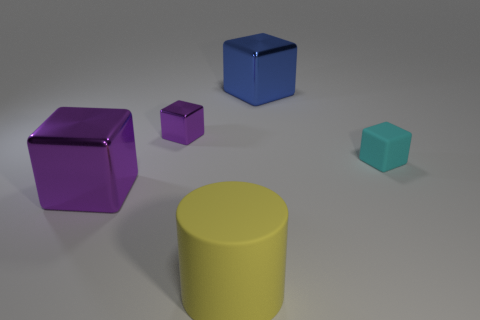There is a yellow matte cylinder; is its size the same as the object that is right of the blue metal object?
Your answer should be compact. No. The object that is both to the right of the yellow cylinder and on the left side of the cyan thing has what shape?
Offer a very short reply. Cube. What is the size of the object that is the same material as the large cylinder?
Provide a succinct answer. Small. There is a rubber thing to the left of the small matte object; what number of cyan cubes are to the right of it?
Your answer should be compact. 1. Is the material of the tiny block to the right of the yellow cylinder the same as the large cylinder?
Offer a very short reply. Yes. Is there any other thing that has the same material as the tiny purple block?
Offer a very short reply. Yes. There is a rubber object that is to the left of the large metallic object right of the large yellow matte cylinder; what is its size?
Give a very brief answer. Large. What size is the thing that is in front of the block that is on the left side of the small cube that is left of the yellow object?
Keep it short and to the point. Large. There is a big object that is behind the large purple block; is its shape the same as the purple metallic thing that is in front of the cyan rubber cube?
Offer a very short reply. Yes. What number of other objects are there of the same color as the small metal cube?
Your answer should be compact. 1. 